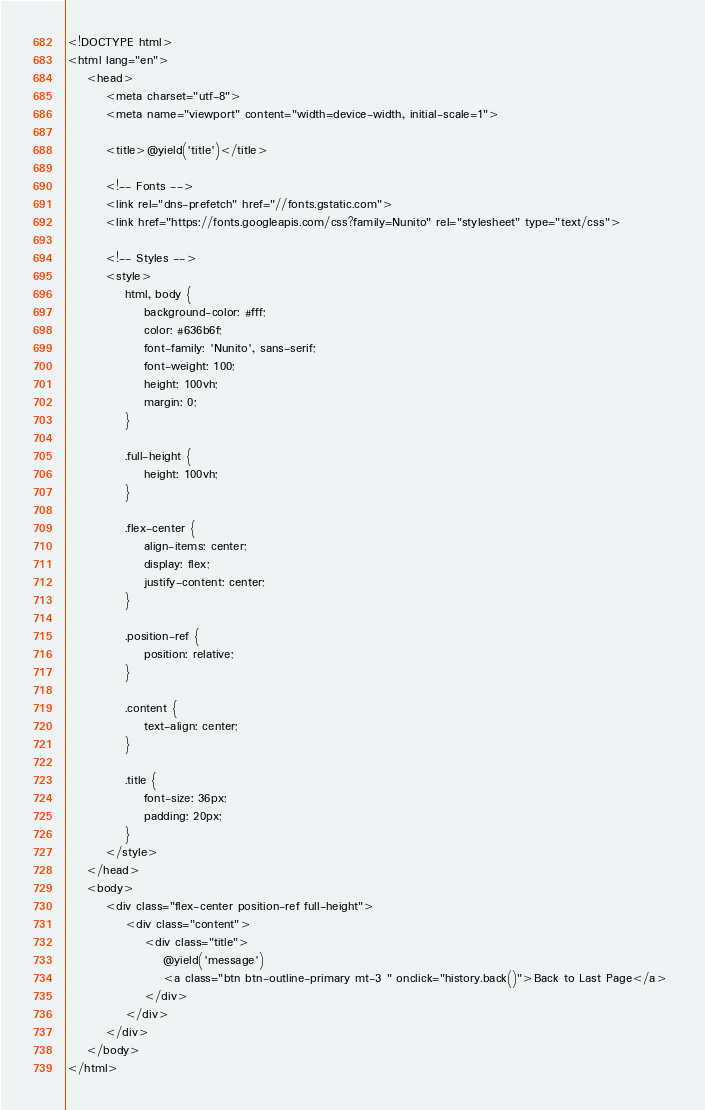Convert code to text. <code><loc_0><loc_0><loc_500><loc_500><_PHP_><!DOCTYPE html>
<html lang="en">
    <head>
        <meta charset="utf-8">
        <meta name="viewport" content="width=device-width, initial-scale=1">

        <title>@yield('title')</title>

        <!-- Fonts -->
        <link rel="dns-prefetch" href="//fonts.gstatic.com">
        <link href="https://fonts.googleapis.com/css?family=Nunito" rel="stylesheet" type="text/css">

        <!-- Styles -->
        <style>
            html, body {
                background-color: #fff;
                color: #636b6f;
                font-family: 'Nunito', sans-serif;
                font-weight: 100;
                height: 100vh;
                margin: 0;
            }

            .full-height {
                height: 100vh;
            }

            .flex-center {
                align-items: center;
                display: flex;
                justify-content: center;
            }

            .position-ref {
                position: relative;
            }

            .content {
                text-align: center;
            }

            .title {
                font-size: 36px;
                padding: 20px;
            }
        </style>
    </head>
    <body>
        <div class="flex-center position-ref full-height">
            <div class="content">
                <div class="title">
                    @yield('message')
                    <a class="btn btn-outline-primary mt-3 " onclick="history.back()">Back to Last Page</a>	
                </div>
            </div>
        </div>
    </body>
</html>
</code> 